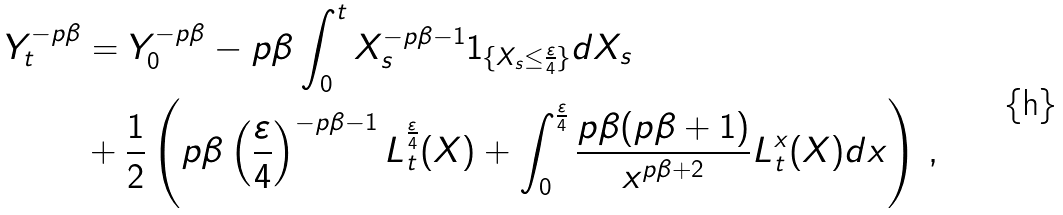Convert formula to latex. <formula><loc_0><loc_0><loc_500><loc_500>Y _ { t } ^ { - p \beta } & = Y _ { 0 } ^ { - p \beta } - p \beta \int _ { 0 } ^ { t } X _ { s } ^ { - p \beta - 1 } 1 _ { \{ X _ { s } \leq \frac { \varepsilon } { 4 } \} } d X _ { s } \\ & + \frac { 1 } { 2 } \left ( p \beta \left ( \frac { \varepsilon } { 4 } \right ) ^ { - p \beta - 1 } L _ { t } ^ { \frac { \varepsilon } { 4 } } ( X ) + \int _ { 0 } ^ { \frac { \varepsilon } { 4 } } \frac { p \beta ( p \beta + 1 ) } { x ^ { p \beta + 2 } } L _ { t } ^ { x } ( X ) d x \right ) \, ,</formula> 